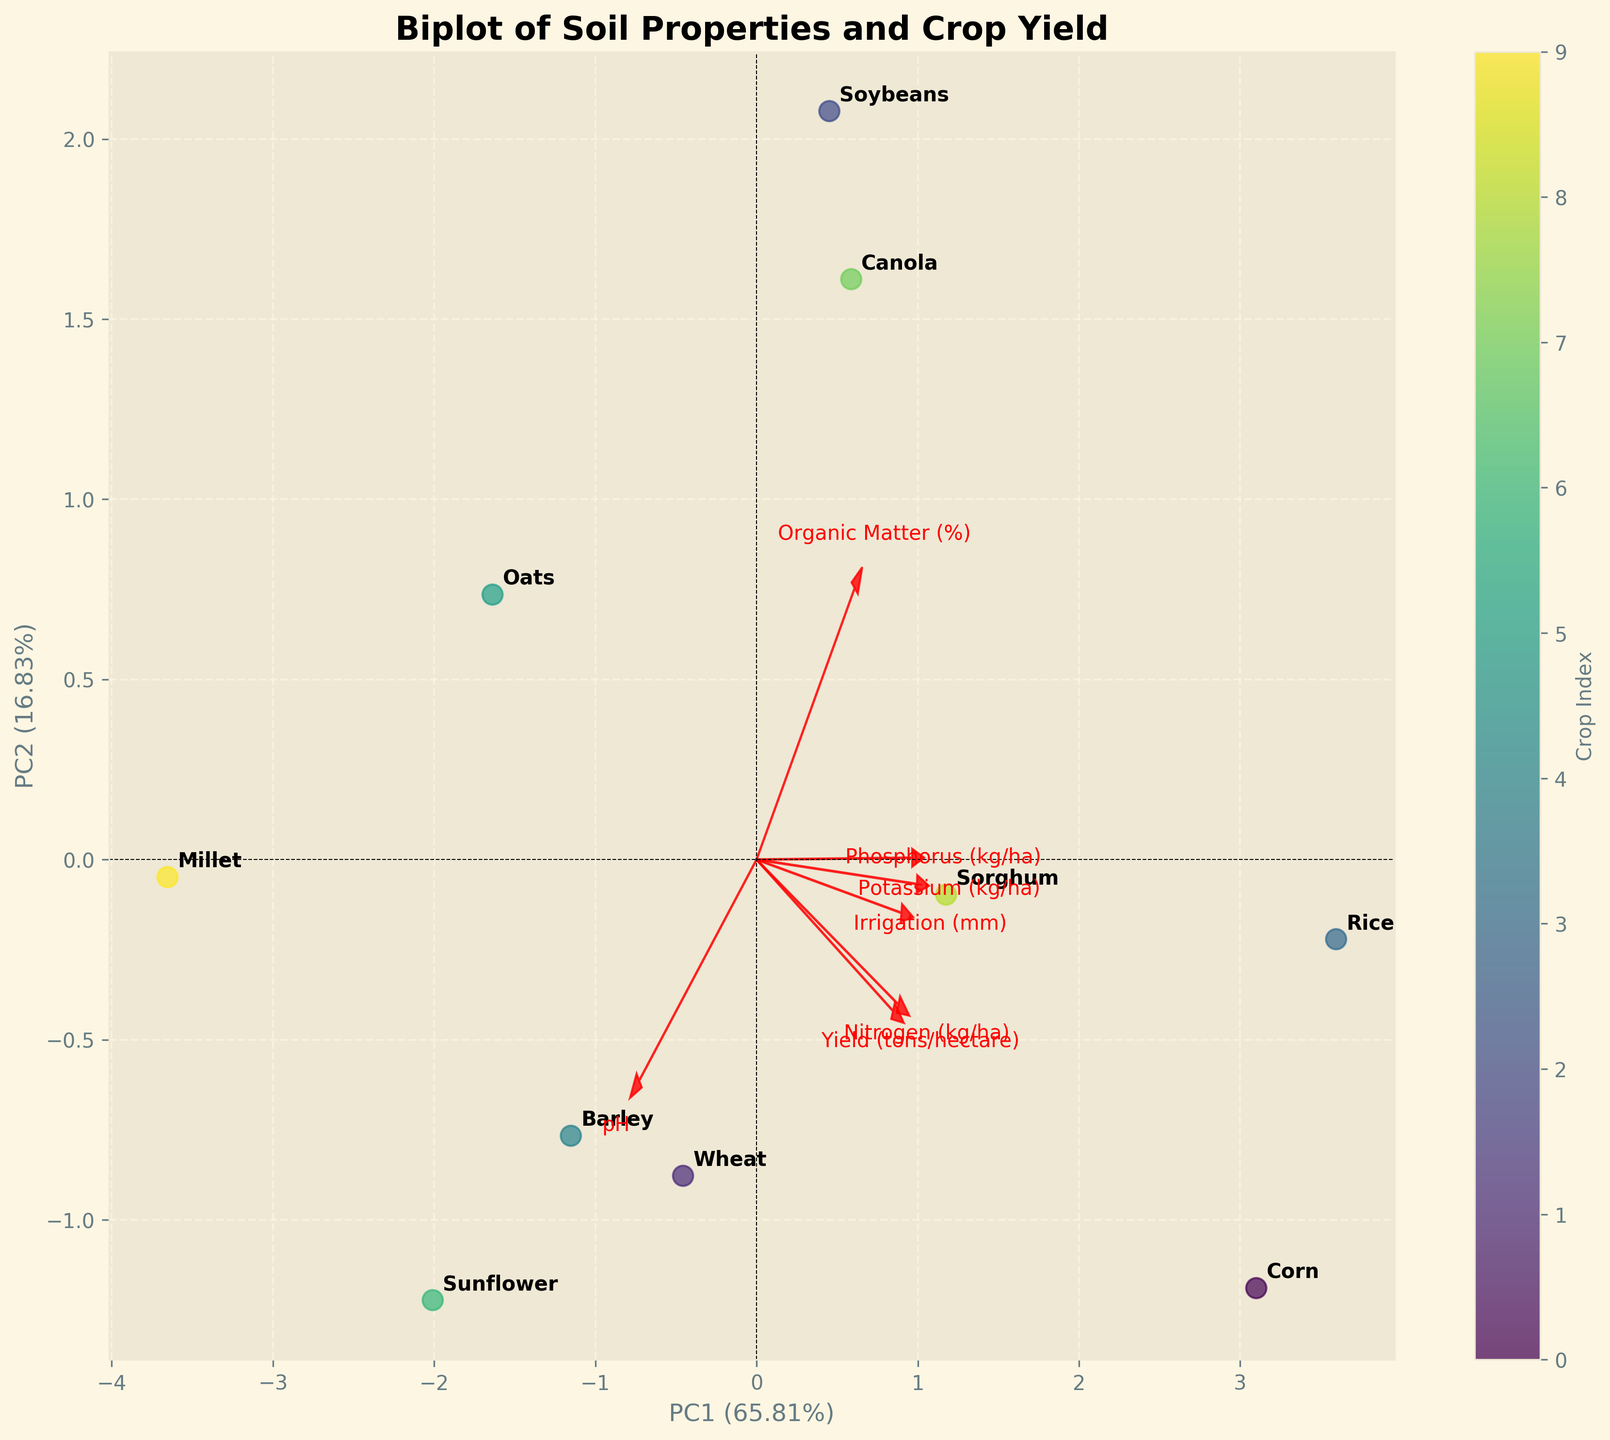What is the title of the biplot? The title of the plot is written at the top of the figure. It reads "Biplot of Soil Properties and Crop Yield."
Answer: Biplot of Soil Properties and Crop Yield Which principal component explains more variance? The x-axis is labeled PC1, and it also has the larger explained variance percentage compared to the y-axis (PC2).
Answer: PC1 How many crops are labeled on the biplot? Each crop is labeled once on the biplot. By counting the labels, we can determine the total number.
Answer: 10 Which crop has the highest nitrogen (kg/ha) according to the biplot? We look for the direction of the arrow labeled "Nitrogen (kg/ha)" and find the crop closest to the end of this arrow.
Answer: Corn Are crops with no-till and conventional tillage methods represented in distinct regions of the biplot? By observing the labeled data points and the tillage methods listed, we compare their positions to see if they cluster in distinct regions.
Answer: No Which feature vector is the longest and what does it indicate? The longest arrows in a biplot indicate the feature that varies the most along the principal components.
Answer: Nitrogen (kg/ha) How much of the total variance is explained by the first two principal components combined? Add the explained variance percentages shown in the x-axis (PC1) and y-axis (PC2).
Answer: 100% Which crop is closest to the origin of the biplot? Locate the origin (0,0) and identify the crop label closest to this point.
Answer: Soybeans Which principal component is most aligned with yield (tons/hectare)? Determine the direction of the yield arrow and see which principal component (PC1 or PC2) it aligns with more.
Answer: PC2 